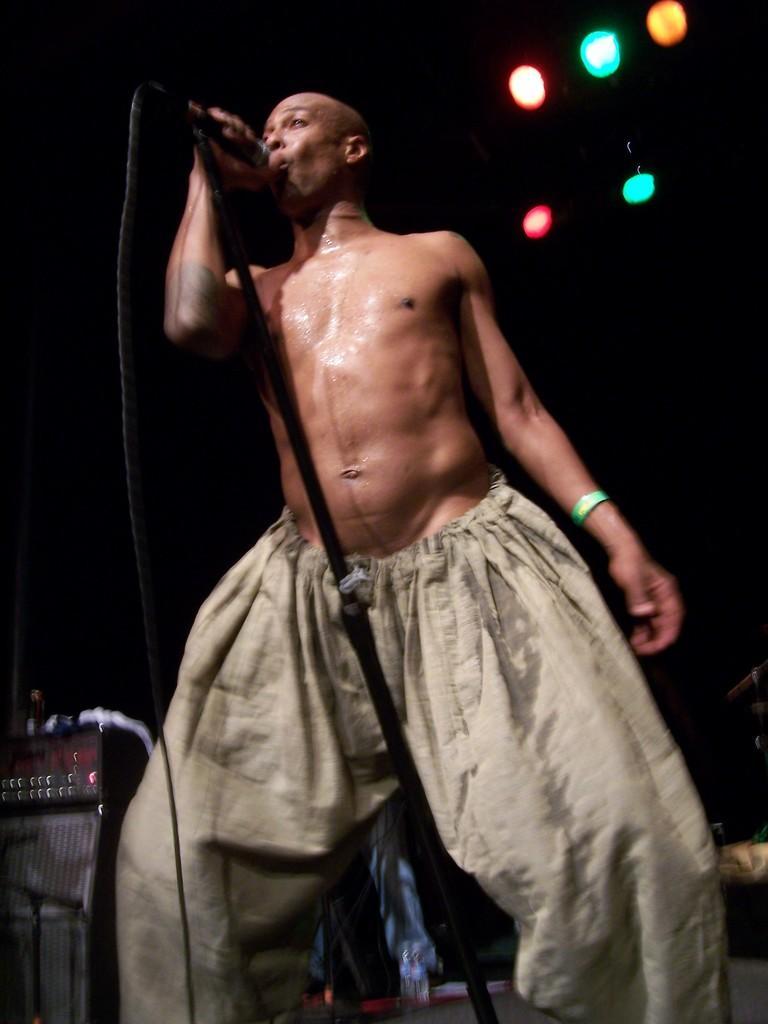How would you summarize this image in a sentence or two? In this picture, we see a man is standing. In front of him, we see a microphone stand. He is holding the microphone in his hand and he is singing the song on the microphone. On the left side, we see the amplifier. In the background, it is black in color. At the top, we see the lights in red, green and orange color. This picture might be clicked in the musical concert. 